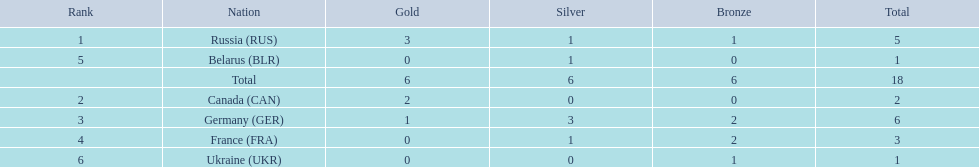Which nations participated? Russia (RUS), Canada (CAN), Germany (GER), France (FRA), Belarus (BLR), Ukraine (UKR). And how many gold medals did they win? 3, 2, 1, 0, 0, 0. What about silver medals? 1, 0, 3, 1, 1, 0. And bronze? 1, 0, 2, 2, 0, 1. Which nation only won gold medals? Canada (CAN). 